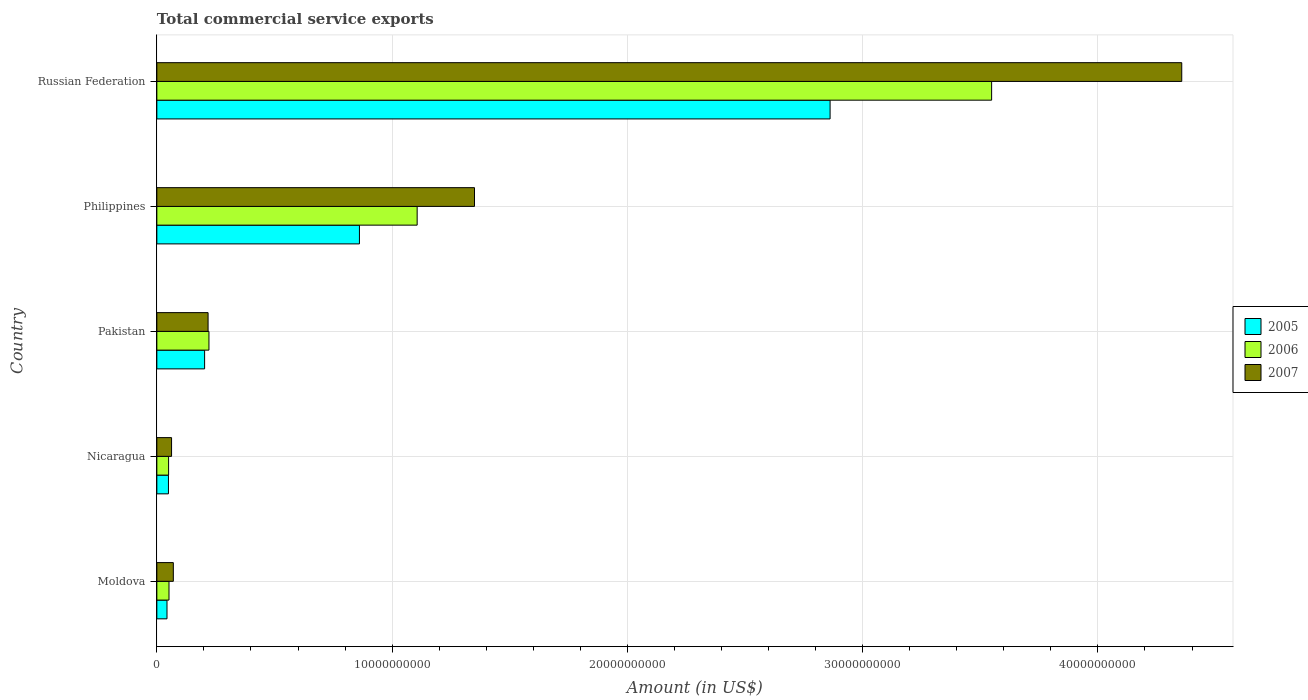How many groups of bars are there?
Your response must be concise. 5. Are the number of bars per tick equal to the number of legend labels?
Offer a very short reply. Yes. Are the number of bars on each tick of the Y-axis equal?
Your response must be concise. Yes. What is the label of the 5th group of bars from the top?
Your answer should be very brief. Moldova. In how many cases, is the number of bars for a given country not equal to the number of legend labels?
Ensure brevity in your answer.  0. What is the total commercial service exports in 2005 in Nicaragua?
Your answer should be very brief. 4.93e+08. Across all countries, what is the maximum total commercial service exports in 2007?
Offer a terse response. 4.36e+1. Across all countries, what is the minimum total commercial service exports in 2007?
Offer a very short reply. 6.25e+08. In which country was the total commercial service exports in 2006 maximum?
Ensure brevity in your answer.  Russian Federation. In which country was the total commercial service exports in 2007 minimum?
Offer a terse response. Nicaragua. What is the total total commercial service exports in 2006 in the graph?
Provide a short and direct response. 4.98e+1. What is the difference between the total commercial service exports in 2007 in Moldova and that in Nicaragua?
Offer a very short reply. 7.50e+07. What is the difference between the total commercial service exports in 2005 in Russian Federation and the total commercial service exports in 2007 in Philippines?
Keep it short and to the point. 1.51e+1. What is the average total commercial service exports in 2006 per country?
Your response must be concise. 9.96e+09. What is the difference between the total commercial service exports in 2005 and total commercial service exports in 2006 in Philippines?
Keep it short and to the point. -2.45e+09. In how many countries, is the total commercial service exports in 2005 greater than 34000000000 US$?
Make the answer very short. 0. What is the ratio of the total commercial service exports in 2007 in Pakistan to that in Russian Federation?
Offer a very short reply. 0.05. Is the total commercial service exports in 2007 in Moldova less than that in Philippines?
Give a very brief answer. Yes. What is the difference between the highest and the second highest total commercial service exports in 2005?
Make the answer very short. 2.00e+1. What is the difference between the highest and the lowest total commercial service exports in 2006?
Give a very brief answer. 3.50e+1. In how many countries, is the total commercial service exports in 2007 greater than the average total commercial service exports in 2007 taken over all countries?
Your answer should be very brief. 2. What does the 2nd bar from the top in Philippines represents?
Your answer should be very brief. 2006. What does the 2nd bar from the bottom in Philippines represents?
Offer a terse response. 2006. Is it the case that in every country, the sum of the total commercial service exports in 2005 and total commercial service exports in 2007 is greater than the total commercial service exports in 2006?
Make the answer very short. Yes. How many bars are there?
Give a very brief answer. 15. Are all the bars in the graph horizontal?
Offer a terse response. Yes. What is the difference between two consecutive major ticks on the X-axis?
Keep it short and to the point. 1.00e+1. Does the graph contain any zero values?
Ensure brevity in your answer.  No. Does the graph contain grids?
Ensure brevity in your answer.  Yes. Where does the legend appear in the graph?
Your answer should be very brief. Center right. How are the legend labels stacked?
Give a very brief answer. Vertical. What is the title of the graph?
Your response must be concise. Total commercial service exports. What is the label or title of the X-axis?
Your response must be concise. Amount (in US$). What is the label or title of the Y-axis?
Offer a terse response. Country. What is the Amount (in US$) of 2005 in Moldova?
Your response must be concise. 4.31e+08. What is the Amount (in US$) of 2006 in Moldova?
Ensure brevity in your answer.  5.17e+08. What is the Amount (in US$) in 2007 in Moldova?
Offer a terse response. 7.00e+08. What is the Amount (in US$) in 2005 in Nicaragua?
Offer a terse response. 4.93e+08. What is the Amount (in US$) in 2006 in Nicaragua?
Make the answer very short. 5.00e+08. What is the Amount (in US$) in 2007 in Nicaragua?
Make the answer very short. 6.25e+08. What is the Amount (in US$) in 2005 in Pakistan?
Your response must be concise. 2.03e+09. What is the Amount (in US$) in 2006 in Pakistan?
Provide a succinct answer. 2.22e+09. What is the Amount (in US$) of 2007 in Pakistan?
Your answer should be compact. 2.18e+09. What is the Amount (in US$) in 2005 in Philippines?
Offer a terse response. 8.61e+09. What is the Amount (in US$) in 2006 in Philippines?
Make the answer very short. 1.11e+1. What is the Amount (in US$) in 2007 in Philippines?
Ensure brevity in your answer.  1.35e+1. What is the Amount (in US$) of 2005 in Russian Federation?
Give a very brief answer. 2.86e+1. What is the Amount (in US$) of 2006 in Russian Federation?
Give a very brief answer. 3.55e+1. What is the Amount (in US$) of 2007 in Russian Federation?
Make the answer very short. 4.36e+1. Across all countries, what is the maximum Amount (in US$) in 2005?
Provide a succinct answer. 2.86e+1. Across all countries, what is the maximum Amount (in US$) of 2006?
Offer a very short reply. 3.55e+1. Across all countries, what is the maximum Amount (in US$) of 2007?
Provide a succinct answer. 4.36e+1. Across all countries, what is the minimum Amount (in US$) of 2005?
Keep it short and to the point. 4.31e+08. Across all countries, what is the minimum Amount (in US$) in 2006?
Ensure brevity in your answer.  5.00e+08. Across all countries, what is the minimum Amount (in US$) of 2007?
Your answer should be compact. 6.25e+08. What is the total Amount (in US$) of 2005 in the graph?
Give a very brief answer. 4.02e+1. What is the total Amount (in US$) of 2006 in the graph?
Offer a terse response. 4.98e+1. What is the total Amount (in US$) of 2007 in the graph?
Offer a very short reply. 6.06e+1. What is the difference between the Amount (in US$) of 2005 in Moldova and that in Nicaragua?
Offer a very short reply. -6.21e+07. What is the difference between the Amount (in US$) of 2006 in Moldova and that in Nicaragua?
Keep it short and to the point. 1.72e+07. What is the difference between the Amount (in US$) in 2007 in Moldova and that in Nicaragua?
Offer a very short reply. 7.50e+07. What is the difference between the Amount (in US$) of 2005 in Moldova and that in Pakistan?
Offer a very short reply. -1.60e+09. What is the difference between the Amount (in US$) in 2006 in Moldova and that in Pakistan?
Make the answer very short. -1.70e+09. What is the difference between the Amount (in US$) of 2007 in Moldova and that in Pakistan?
Provide a succinct answer. -1.48e+09. What is the difference between the Amount (in US$) in 2005 in Moldova and that in Philippines?
Give a very brief answer. -8.18e+09. What is the difference between the Amount (in US$) of 2006 in Moldova and that in Philippines?
Make the answer very short. -1.05e+1. What is the difference between the Amount (in US$) of 2007 in Moldova and that in Philippines?
Your response must be concise. -1.28e+1. What is the difference between the Amount (in US$) in 2005 in Moldova and that in Russian Federation?
Offer a terse response. -2.82e+1. What is the difference between the Amount (in US$) in 2006 in Moldova and that in Russian Federation?
Your response must be concise. -3.50e+1. What is the difference between the Amount (in US$) in 2007 in Moldova and that in Russian Federation?
Ensure brevity in your answer.  -4.29e+1. What is the difference between the Amount (in US$) in 2005 in Nicaragua and that in Pakistan?
Offer a terse response. -1.54e+09. What is the difference between the Amount (in US$) in 2006 in Nicaragua and that in Pakistan?
Your response must be concise. -1.72e+09. What is the difference between the Amount (in US$) in 2007 in Nicaragua and that in Pakistan?
Ensure brevity in your answer.  -1.55e+09. What is the difference between the Amount (in US$) of 2005 in Nicaragua and that in Philippines?
Provide a short and direct response. -8.12e+09. What is the difference between the Amount (in US$) of 2006 in Nicaragua and that in Philippines?
Ensure brevity in your answer.  -1.06e+1. What is the difference between the Amount (in US$) in 2007 in Nicaragua and that in Philippines?
Ensure brevity in your answer.  -1.29e+1. What is the difference between the Amount (in US$) in 2005 in Nicaragua and that in Russian Federation?
Keep it short and to the point. -2.81e+1. What is the difference between the Amount (in US$) of 2006 in Nicaragua and that in Russian Federation?
Make the answer very short. -3.50e+1. What is the difference between the Amount (in US$) of 2007 in Nicaragua and that in Russian Federation?
Your response must be concise. -4.29e+1. What is the difference between the Amount (in US$) in 2005 in Pakistan and that in Philippines?
Keep it short and to the point. -6.58e+09. What is the difference between the Amount (in US$) of 2006 in Pakistan and that in Philippines?
Give a very brief answer. -8.85e+09. What is the difference between the Amount (in US$) of 2007 in Pakistan and that in Philippines?
Your response must be concise. -1.13e+1. What is the difference between the Amount (in US$) of 2005 in Pakistan and that in Russian Federation?
Provide a short and direct response. -2.66e+1. What is the difference between the Amount (in US$) of 2006 in Pakistan and that in Russian Federation?
Provide a short and direct response. -3.33e+1. What is the difference between the Amount (in US$) in 2007 in Pakistan and that in Russian Federation?
Your answer should be compact. -4.14e+1. What is the difference between the Amount (in US$) of 2005 in Philippines and that in Russian Federation?
Provide a succinct answer. -2.00e+1. What is the difference between the Amount (in US$) in 2006 in Philippines and that in Russian Federation?
Your response must be concise. -2.44e+1. What is the difference between the Amount (in US$) in 2007 in Philippines and that in Russian Federation?
Your response must be concise. -3.01e+1. What is the difference between the Amount (in US$) in 2005 in Moldova and the Amount (in US$) in 2006 in Nicaragua?
Keep it short and to the point. -6.83e+07. What is the difference between the Amount (in US$) in 2005 in Moldova and the Amount (in US$) in 2007 in Nicaragua?
Make the answer very short. -1.94e+08. What is the difference between the Amount (in US$) of 2006 in Moldova and the Amount (in US$) of 2007 in Nicaragua?
Your answer should be compact. -1.09e+08. What is the difference between the Amount (in US$) in 2005 in Moldova and the Amount (in US$) in 2006 in Pakistan?
Your answer should be compact. -1.78e+09. What is the difference between the Amount (in US$) of 2005 in Moldova and the Amount (in US$) of 2007 in Pakistan?
Ensure brevity in your answer.  -1.75e+09. What is the difference between the Amount (in US$) of 2006 in Moldova and the Amount (in US$) of 2007 in Pakistan?
Provide a short and direct response. -1.66e+09. What is the difference between the Amount (in US$) in 2005 in Moldova and the Amount (in US$) in 2006 in Philippines?
Your response must be concise. -1.06e+1. What is the difference between the Amount (in US$) of 2005 in Moldova and the Amount (in US$) of 2007 in Philippines?
Offer a very short reply. -1.31e+1. What is the difference between the Amount (in US$) of 2006 in Moldova and the Amount (in US$) of 2007 in Philippines?
Give a very brief answer. -1.30e+1. What is the difference between the Amount (in US$) of 2005 in Moldova and the Amount (in US$) of 2006 in Russian Federation?
Ensure brevity in your answer.  -3.51e+1. What is the difference between the Amount (in US$) in 2005 in Moldova and the Amount (in US$) in 2007 in Russian Federation?
Keep it short and to the point. -4.31e+1. What is the difference between the Amount (in US$) of 2006 in Moldova and the Amount (in US$) of 2007 in Russian Federation?
Provide a short and direct response. -4.30e+1. What is the difference between the Amount (in US$) in 2005 in Nicaragua and the Amount (in US$) in 2006 in Pakistan?
Give a very brief answer. -1.72e+09. What is the difference between the Amount (in US$) of 2005 in Nicaragua and the Amount (in US$) of 2007 in Pakistan?
Make the answer very short. -1.68e+09. What is the difference between the Amount (in US$) in 2006 in Nicaragua and the Amount (in US$) in 2007 in Pakistan?
Ensure brevity in your answer.  -1.68e+09. What is the difference between the Amount (in US$) of 2005 in Nicaragua and the Amount (in US$) of 2006 in Philippines?
Make the answer very short. -1.06e+1. What is the difference between the Amount (in US$) of 2005 in Nicaragua and the Amount (in US$) of 2007 in Philippines?
Provide a short and direct response. -1.30e+1. What is the difference between the Amount (in US$) in 2006 in Nicaragua and the Amount (in US$) in 2007 in Philippines?
Provide a short and direct response. -1.30e+1. What is the difference between the Amount (in US$) in 2005 in Nicaragua and the Amount (in US$) in 2006 in Russian Federation?
Your response must be concise. -3.50e+1. What is the difference between the Amount (in US$) of 2005 in Nicaragua and the Amount (in US$) of 2007 in Russian Federation?
Make the answer very short. -4.31e+1. What is the difference between the Amount (in US$) in 2006 in Nicaragua and the Amount (in US$) in 2007 in Russian Federation?
Provide a succinct answer. -4.31e+1. What is the difference between the Amount (in US$) of 2005 in Pakistan and the Amount (in US$) of 2006 in Philippines?
Make the answer very short. -9.03e+09. What is the difference between the Amount (in US$) in 2005 in Pakistan and the Amount (in US$) in 2007 in Philippines?
Make the answer very short. -1.15e+1. What is the difference between the Amount (in US$) in 2006 in Pakistan and the Amount (in US$) in 2007 in Philippines?
Your response must be concise. -1.13e+1. What is the difference between the Amount (in US$) of 2005 in Pakistan and the Amount (in US$) of 2006 in Russian Federation?
Your answer should be very brief. -3.35e+1. What is the difference between the Amount (in US$) in 2005 in Pakistan and the Amount (in US$) in 2007 in Russian Federation?
Keep it short and to the point. -4.15e+1. What is the difference between the Amount (in US$) in 2006 in Pakistan and the Amount (in US$) in 2007 in Russian Federation?
Offer a terse response. -4.13e+1. What is the difference between the Amount (in US$) of 2005 in Philippines and the Amount (in US$) of 2006 in Russian Federation?
Your answer should be compact. -2.69e+1. What is the difference between the Amount (in US$) of 2005 in Philippines and the Amount (in US$) of 2007 in Russian Federation?
Make the answer very short. -3.50e+1. What is the difference between the Amount (in US$) in 2006 in Philippines and the Amount (in US$) in 2007 in Russian Federation?
Offer a terse response. -3.25e+1. What is the average Amount (in US$) of 2005 per country?
Offer a terse response. 8.04e+09. What is the average Amount (in US$) in 2006 per country?
Keep it short and to the point. 9.96e+09. What is the average Amount (in US$) in 2007 per country?
Offer a very short reply. 1.21e+1. What is the difference between the Amount (in US$) of 2005 and Amount (in US$) of 2006 in Moldova?
Make the answer very short. -8.55e+07. What is the difference between the Amount (in US$) in 2005 and Amount (in US$) in 2007 in Moldova?
Your answer should be very brief. -2.69e+08. What is the difference between the Amount (in US$) in 2006 and Amount (in US$) in 2007 in Moldova?
Provide a short and direct response. -1.84e+08. What is the difference between the Amount (in US$) in 2005 and Amount (in US$) in 2006 in Nicaragua?
Give a very brief answer. -6.20e+06. What is the difference between the Amount (in US$) in 2005 and Amount (in US$) in 2007 in Nicaragua?
Keep it short and to the point. -1.32e+08. What is the difference between the Amount (in US$) of 2006 and Amount (in US$) of 2007 in Nicaragua?
Your answer should be compact. -1.26e+08. What is the difference between the Amount (in US$) in 2005 and Amount (in US$) in 2006 in Pakistan?
Your answer should be compact. -1.85e+08. What is the difference between the Amount (in US$) in 2005 and Amount (in US$) in 2007 in Pakistan?
Make the answer very short. -1.48e+08. What is the difference between the Amount (in US$) of 2006 and Amount (in US$) of 2007 in Pakistan?
Offer a very short reply. 3.73e+07. What is the difference between the Amount (in US$) in 2005 and Amount (in US$) in 2006 in Philippines?
Your response must be concise. -2.45e+09. What is the difference between the Amount (in US$) of 2005 and Amount (in US$) of 2007 in Philippines?
Keep it short and to the point. -4.89e+09. What is the difference between the Amount (in US$) of 2006 and Amount (in US$) of 2007 in Philippines?
Your answer should be very brief. -2.44e+09. What is the difference between the Amount (in US$) in 2005 and Amount (in US$) in 2006 in Russian Federation?
Provide a short and direct response. -6.87e+09. What is the difference between the Amount (in US$) of 2005 and Amount (in US$) of 2007 in Russian Federation?
Offer a terse response. -1.49e+1. What is the difference between the Amount (in US$) in 2006 and Amount (in US$) in 2007 in Russian Federation?
Make the answer very short. -8.08e+09. What is the ratio of the Amount (in US$) of 2005 in Moldova to that in Nicaragua?
Provide a short and direct response. 0.87. What is the ratio of the Amount (in US$) of 2006 in Moldova to that in Nicaragua?
Provide a short and direct response. 1.03. What is the ratio of the Amount (in US$) of 2007 in Moldova to that in Nicaragua?
Provide a succinct answer. 1.12. What is the ratio of the Amount (in US$) of 2005 in Moldova to that in Pakistan?
Give a very brief answer. 0.21. What is the ratio of the Amount (in US$) in 2006 in Moldova to that in Pakistan?
Offer a terse response. 0.23. What is the ratio of the Amount (in US$) in 2007 in Moldova to that in Pakistan?
Give a very brief answer. 0.32. What is the ratio of the Amount (in US$) of 2005 in Moldova to that in Philippines?
Your response must be concise. 0.05. What is the ratio of the Amount (in US$) of 2006 in Moldova to that in Philippines?
Offer a very short reply. 0.05. What is the ratio of the Amount (in US$) of 2007 in Moldova to that in Philippines?
Your answer should be compact. 0.05. What is the ratio of the Amount (in US$) in 2005 in Moldova to that in Russian Federation?
Provide a short and direct response. 0.02. What is the ratio of the Amount (in US$) in 2006 in Moldova to that in Russian Federation?
Give a very brief answer. 0.01. What is the ratio of the Amount (in US$) of 2007 in Moldova to that in Russian Federation?
Ensure brevity in your answer.  0.02. What is the ratio of the Amount (in US$) of 2005 in Nicaragua to that in Pakistan?
Offer a very short reply. 0.24. What is the ratio of the Amount (in US$) of 2006 in Nicaragua to that in Pakistan?
Keep it short and to the point. 0.23. What is the ratio of the Amount (in US$) in 2007 in Nicaragua to that in Pakistan?
Your answer should be compact. 0.29. What is the ratio of the Amount (in US$) in 2005 in Nicaragua to that in Philippines?
Provide a succinct answer. 0.06. What is the ratio of the Amount (in US$) in 2006 in Nicaragua to that in Philippines?
Your response must be concise. 0.05. What is the ratio of the Amount (in US$) in 2007 in Nicaragua to that in Philippines?
Make the answer very short. 0.05. What is the ratio of the Amount (in US$) of 2005 in Nicaragua to that in Russian Federation?
Your answer should be very brief. 0.02. What is the ratio of the Amount (in US$) of 2006 in Nicaragua to that in Russian Federation?
Your answer should be compact. 0.01. What is the ratio of the Amount (in US$) in 2007 in Nicaragua to that in Russian Federation?
Your response must be concise. 0.01. What is the ratio of the Amount (in US$) in 2005 in Pakistan to that in Philippines?
Offer a terse response. 0.24. What is the ratio of the Amount (in US$) in 2006 in Pakistan to that in Philippines?
Keep it short and to the point. 0.2. What is the ratio of the Amount (in US$) of 2007 in Pakistan to that in Philippines?
Offer a very short reply. 0.16. What is the ratio of the Amount (in US$) in 2005 in Pakistan to that in Russian Federation?
Your answer should be compact. 0.07. What is the ratio of the Amount (in US$) in 2006 in Pakistan to that in Russian Federation?
Provide a succinct answer. 0.06. What is the ratio of the Amount (in US$) in 2005 in Philippines to that in Russian Federation?
Your response must be concise. 0.3. What is the ratio of the Amount (in US$) of 2006 in Philippines to that in Russian Federation?
Offer a very short reply. 0.31. What is the ratio of the Amount (in US$) of 2007 in Philippines to that in Russian Federation?
Your response must be concise. 0.31. What is the difference between the highest and the second highest Amount (in US$) of 2005?
Your response must be concise. 2.00e+1. What is the difference between the highest and the second highest Amount (in US$) of 2006?
Keep it short and to the point. 2.44e+1. What is the difference between the highest and the second highest Amount (in US$) of 2007?
Ensure brevity in your answer.  3.01e+1. What is the difference between the highest and the lowest Amount (in US$) of 2005?
Offer a very short reply. 2.82e+1. What is the difference between the highest and the lowest Amount (in US$) of 2006?
Offer a terse response. 3.50e+1. What is the difference between the highest and the lowest Amount (in US$) of 2007?
Make the answer very short. 4.29e+1. 